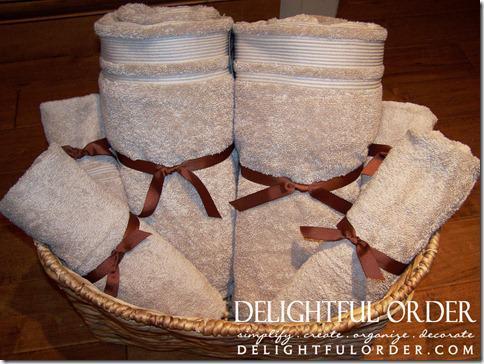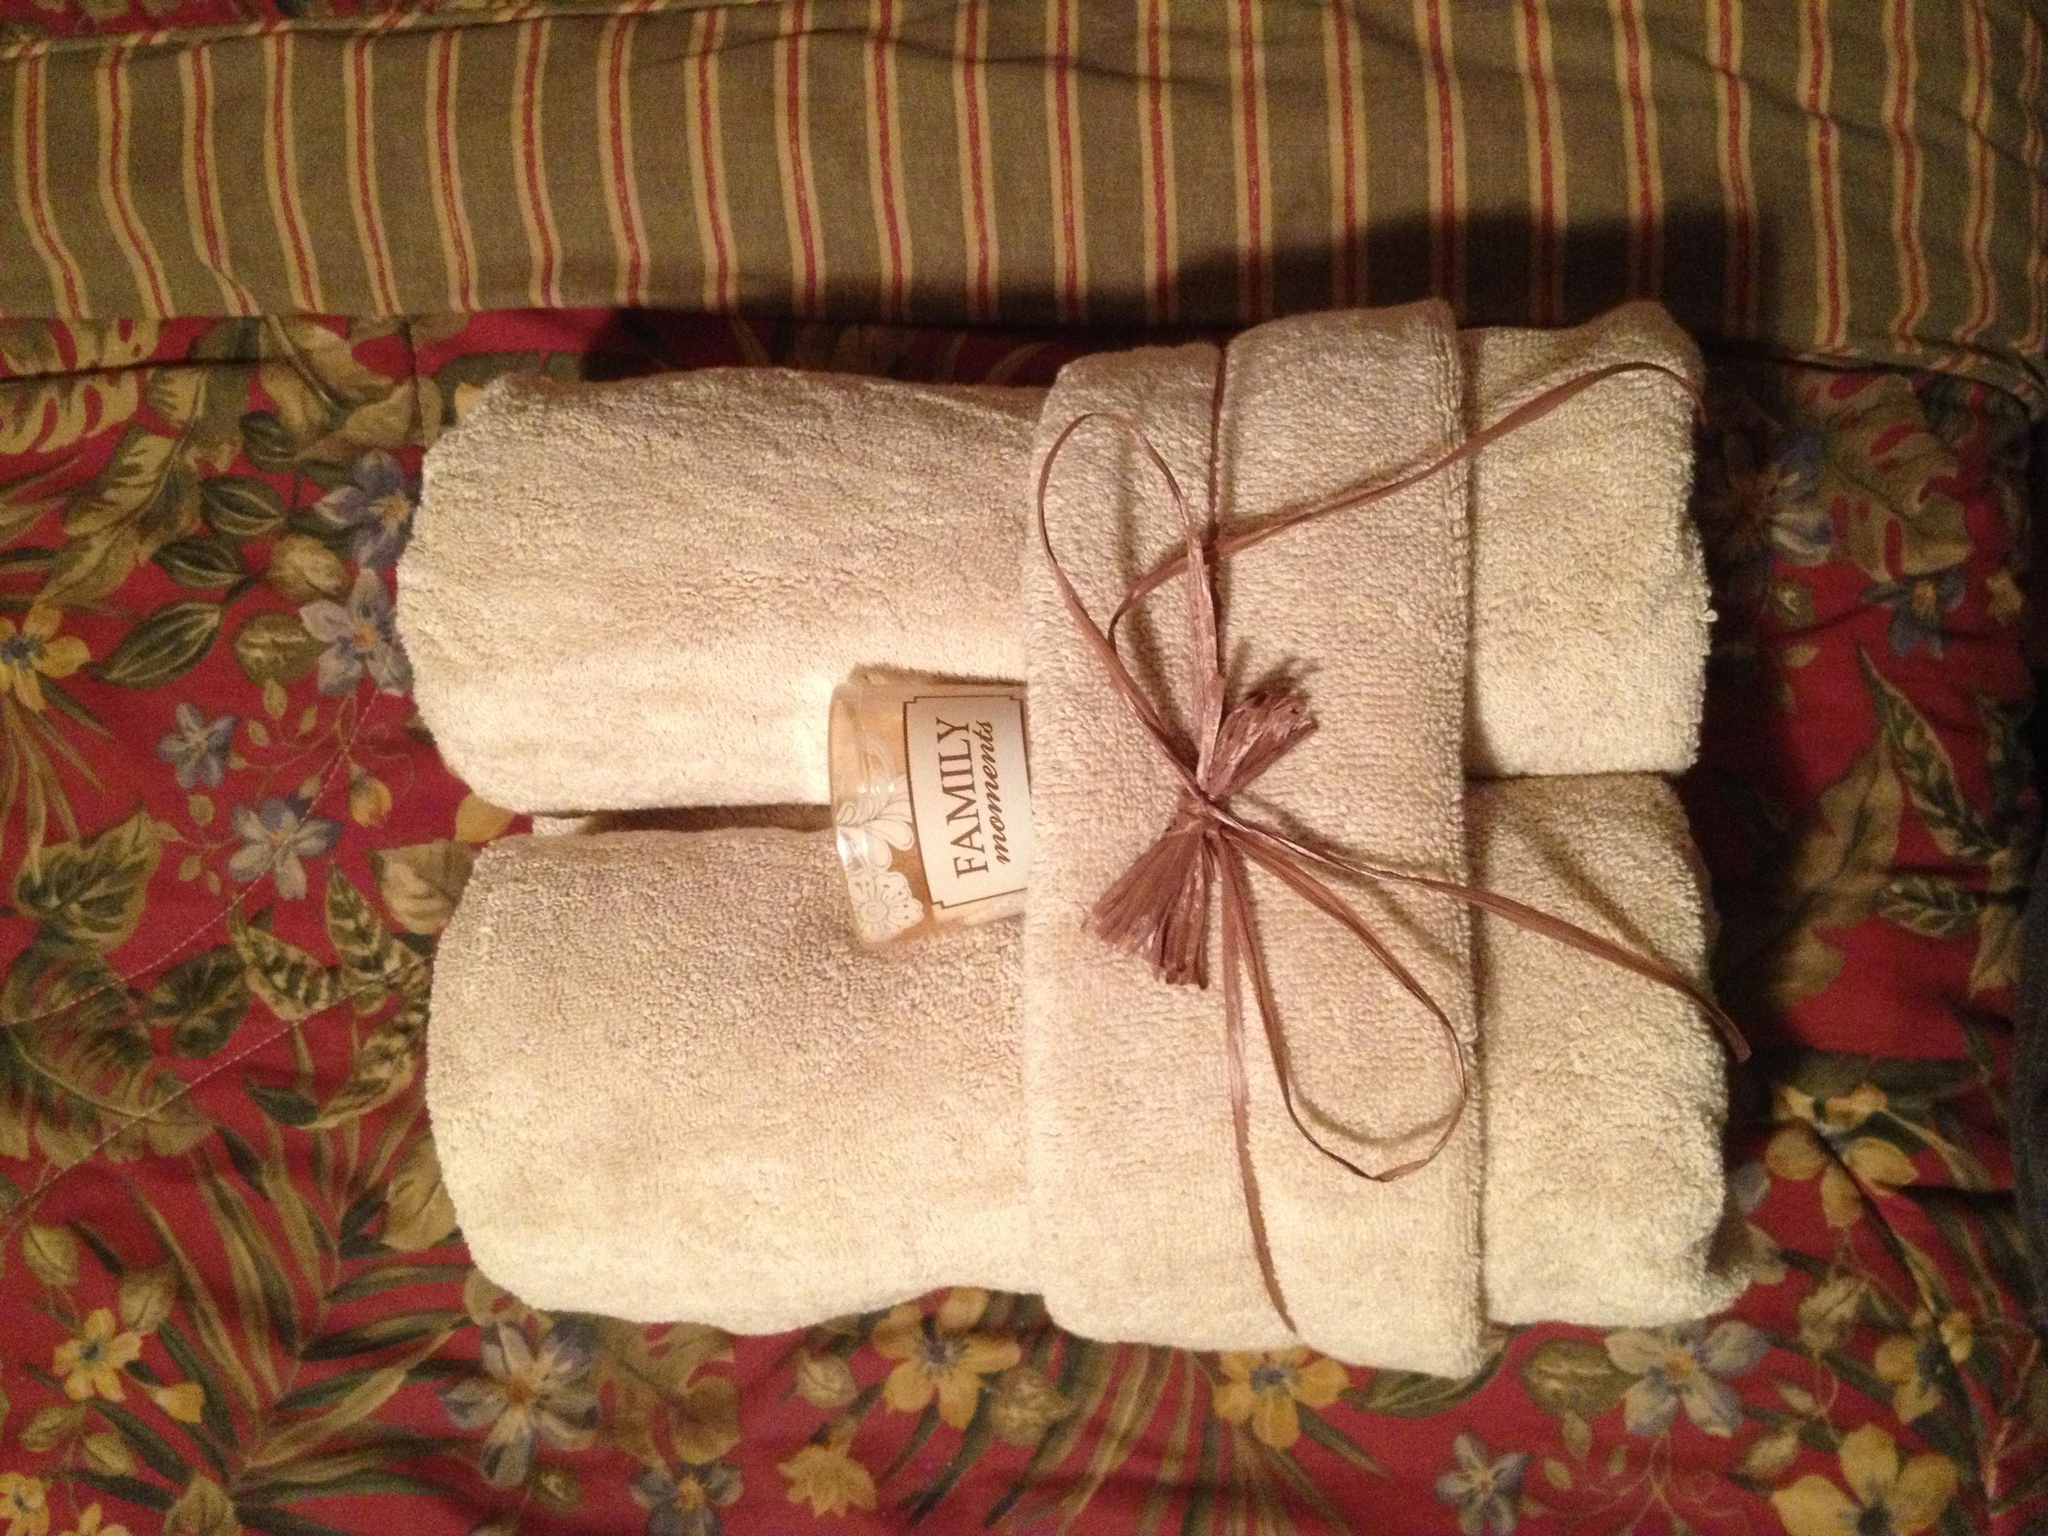The first image is the image on the left, the second image is the image on the right. Examine the images to the left and right. Is the description "There is a basket in the image on the left." accurate? Answer yes or no. Yes. The first image is the image on the left, the second image is the image on the right. Given the left and right images, does the statement "The towels in the right image are not displayed in a basket-type container." hold true? Answer yes or no. Yes. 